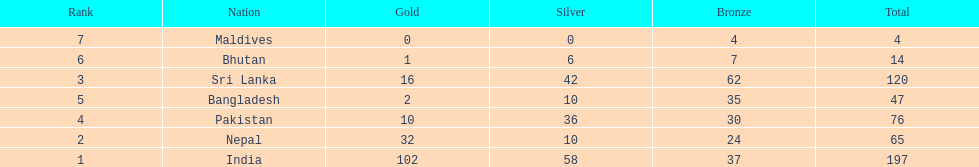How many gold medals did india win? 102. 